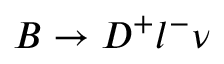<formula> <loc_0><loc_0><loc_500><loc_500>B \to D ^ { + } l ^ { - } \nu</formula> 